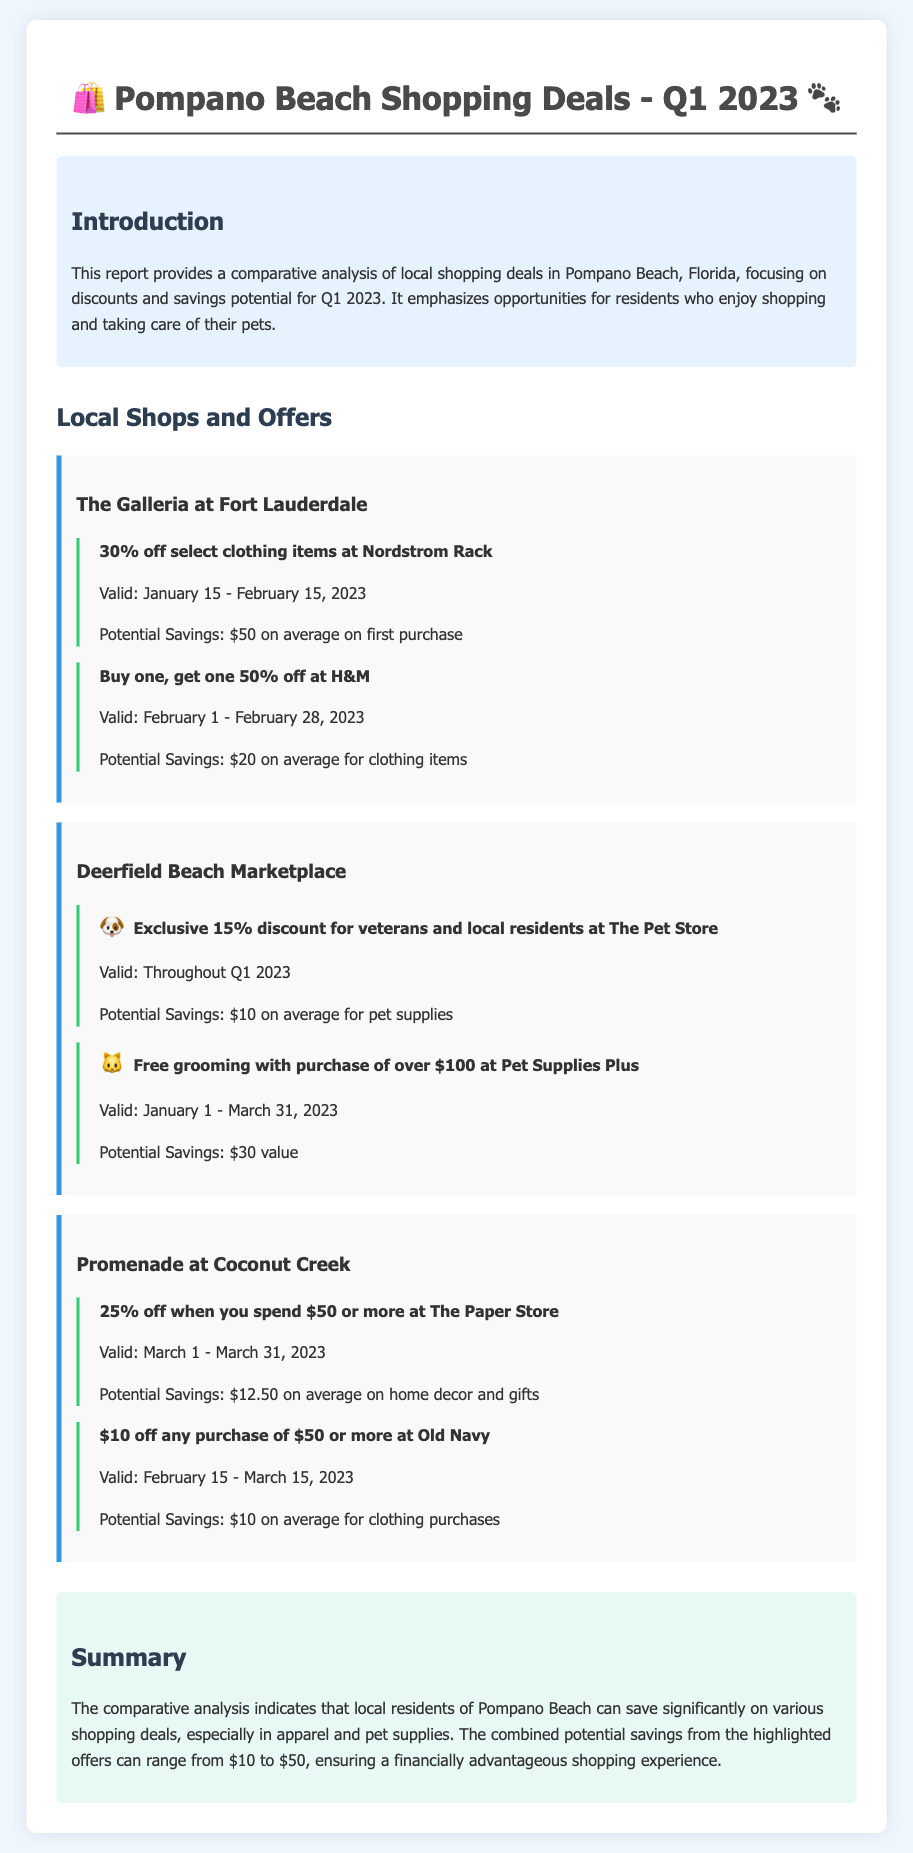what is the discount percentage at Nordstrom Rack? The document states that there is a 30% off discount available at Nordstrom Rack.
Answer: 30% when is the H&M promotion valid? The promotion for H&M is valid from February 1 to February 28, 2023.
Answer: February 1 - February 28, 2023 what is the potential savings at The Pet Store for local residents? The potential savings at The Pet Store for local residents is $10 on average for pet supplies.
Answer: $10 who receives an exclusive discount at The Pet Store? The exclusive discount at The Pet Store is for veterans and local residents.
Answer: veterans and local residents what is required to get free grooming at Pet Supplies Plus? Free grooming is offered with a purchase of over $100 at Pet Supplies Plus.
Answer: purchase of over $100 which shopping center has a 25% off promotion? The promotion offering 25% off is at The Paper Store in Promenade at Coconut Creek.
Answer: Promenade at Coconut Creek what is the average potential savings for clothing at Old Navy? The average potential savings for clothing purchases at Old Navy is $10.
Answer: $10 during which month does the promotion at The Paper Store end? The promotion at The Paper Store ends in March 2023.
Answer: March 2023 what is the overall theme of the report? The overall theme of the report is about comparative analysis of local shopping deals focusing on discounts and savings.
Answer: comparative analysis of local shopping deals 